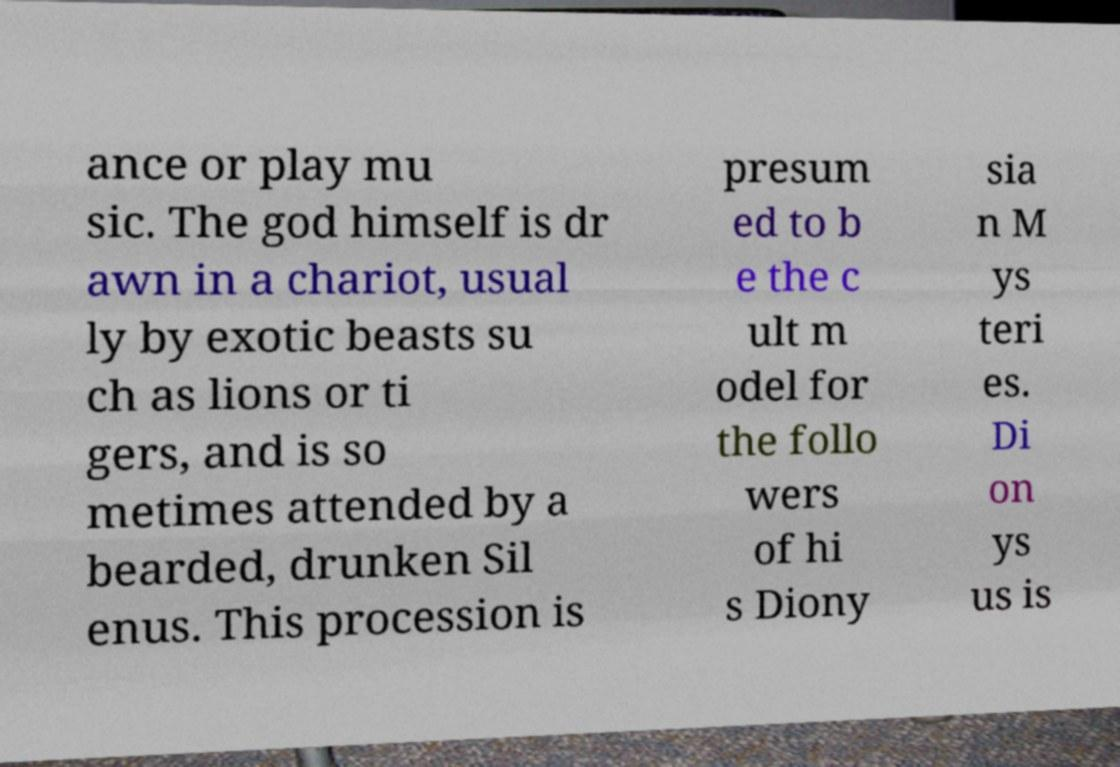There's text embedded in this image that I need extracted. Can you transcribe it verbatim? ance or play mu sic. The god himself is dr awn in a chariot, usual ly by exotic beasts su ch as lions or ti gers, and is so metimes attended by a bearded, drunken Sil enus. This procession is presum ed to b e the c ult m odel for the follo wers of hi s Diony sia n M ys teri es. Di on ys us is 